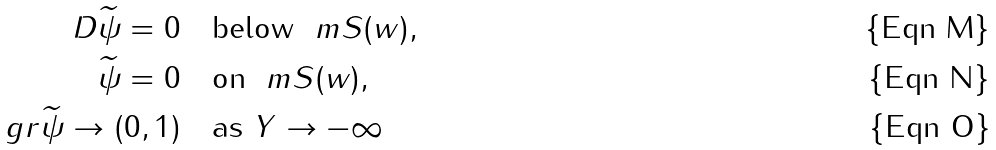Convert formula to latex. <formula><loc_0><loc_0><loc_500><loc_500>\ D \widetilde { \psi } = 0 & \quad \text {below } \ m S ( w ) , \\ \widetilde { \psi } = 0 & \quad \text {on } \ m S ( w ) , \\ \ g r \widetilde { \psi } \to ( 0 , 1 ) & \quad \text {as } Y \to - \infty</formula> 